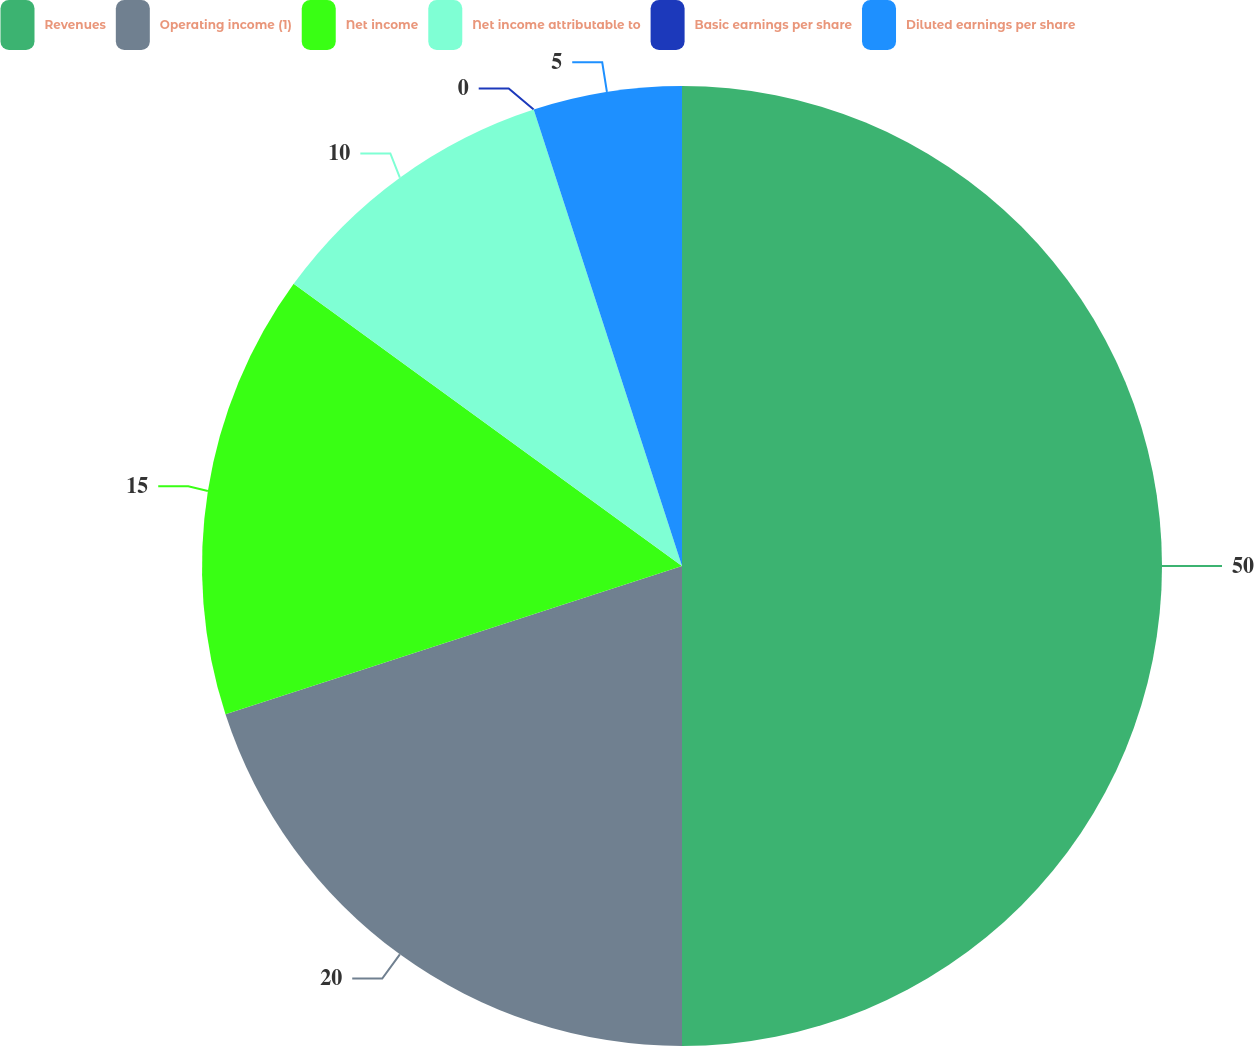Convert chart to OTSL. <chart><loc_0><loc_0><loc_500><loc_500><pie_chart><fcel>Revenues<fcel>Operating income (1)<fcel>Net income<fcel>Net income attributable to<fcel>Basic earnings per share<fcel>Diluted earnings per share<nl><fcel>50.0%<fcel>20.0%<fcel>15.0%<fcel>10.0%<fcel>0.0%<fcel>5.0%<nl></chart> 